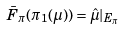Convert formula to latex. <formula><loc_0><loc_0><loc_500><loc_500>\bar { F } _ { \pi } ( \pi _ { 1 } ( \mu ) ) = \hat { \mu } | _ { E _ { \pi } }</formula> 